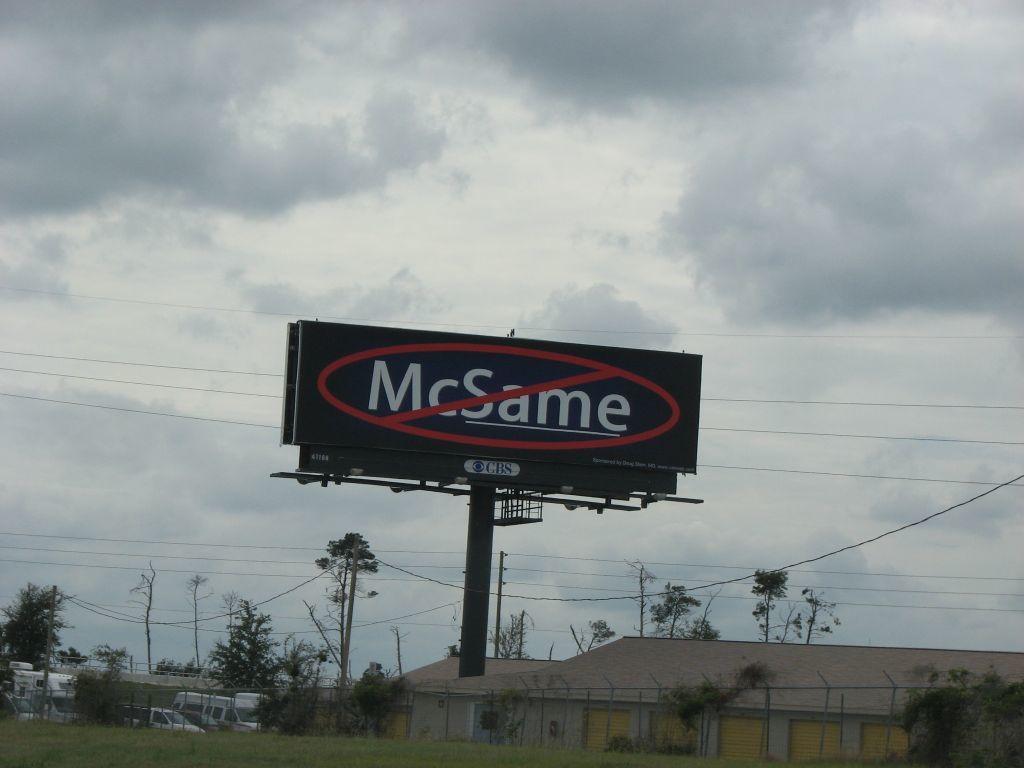What is the name on the pole?
Make the answer very short. Mcsame. 